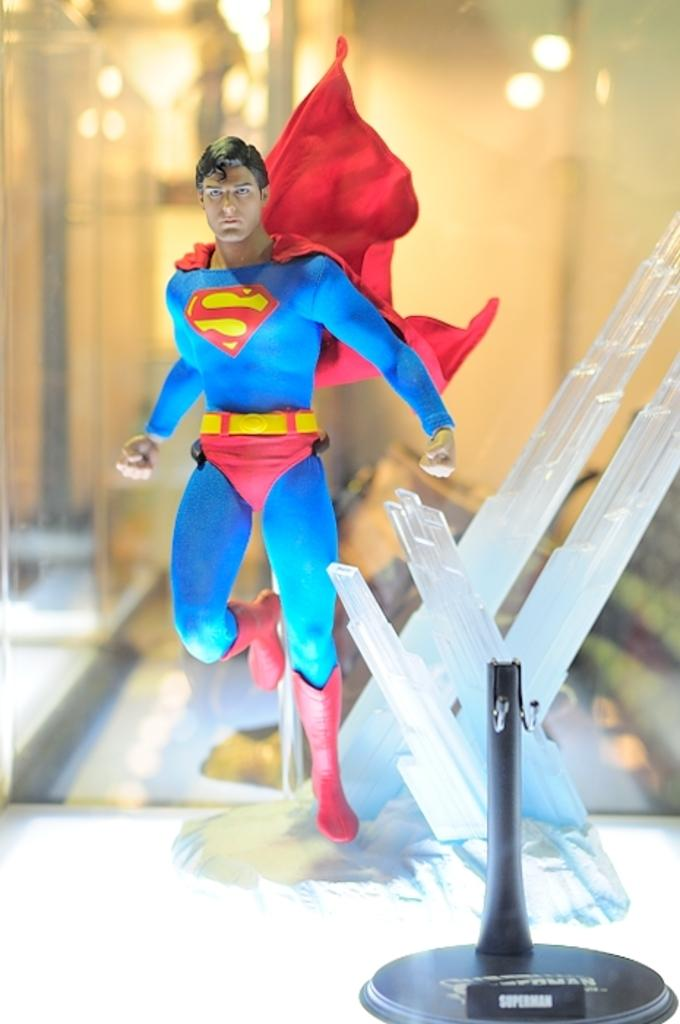What type of toy is present in the image? There is a superman toy in the image. What is the superman toy placed on or near? There is a stand in the image. What can be seen in the background of the image? Lights are visible in the background of the image. How would you describe the clarity of the background in the image? The background of the image appears blurry. What type of writing can be seen on the stove in the image? There is no stove present in the image, and therefore no writing can be observed. 